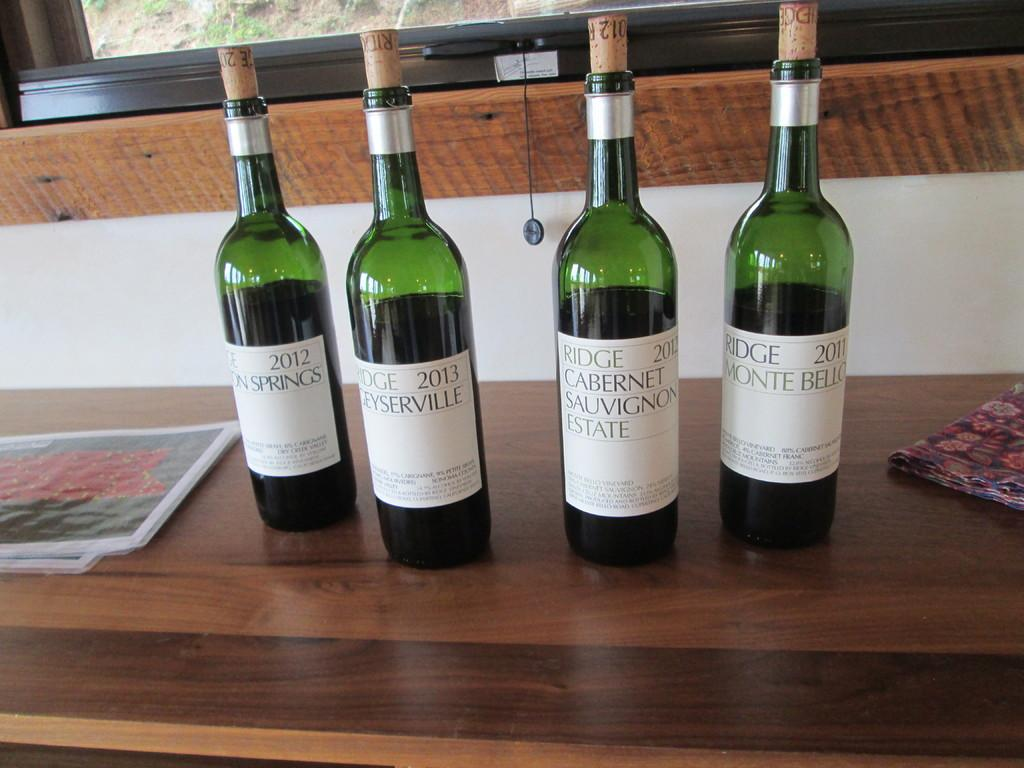<image>
Offer a succinct explanation of the picture presented. 4 wine bottles branded Ridge cabernet Sauvignon Estate.. 